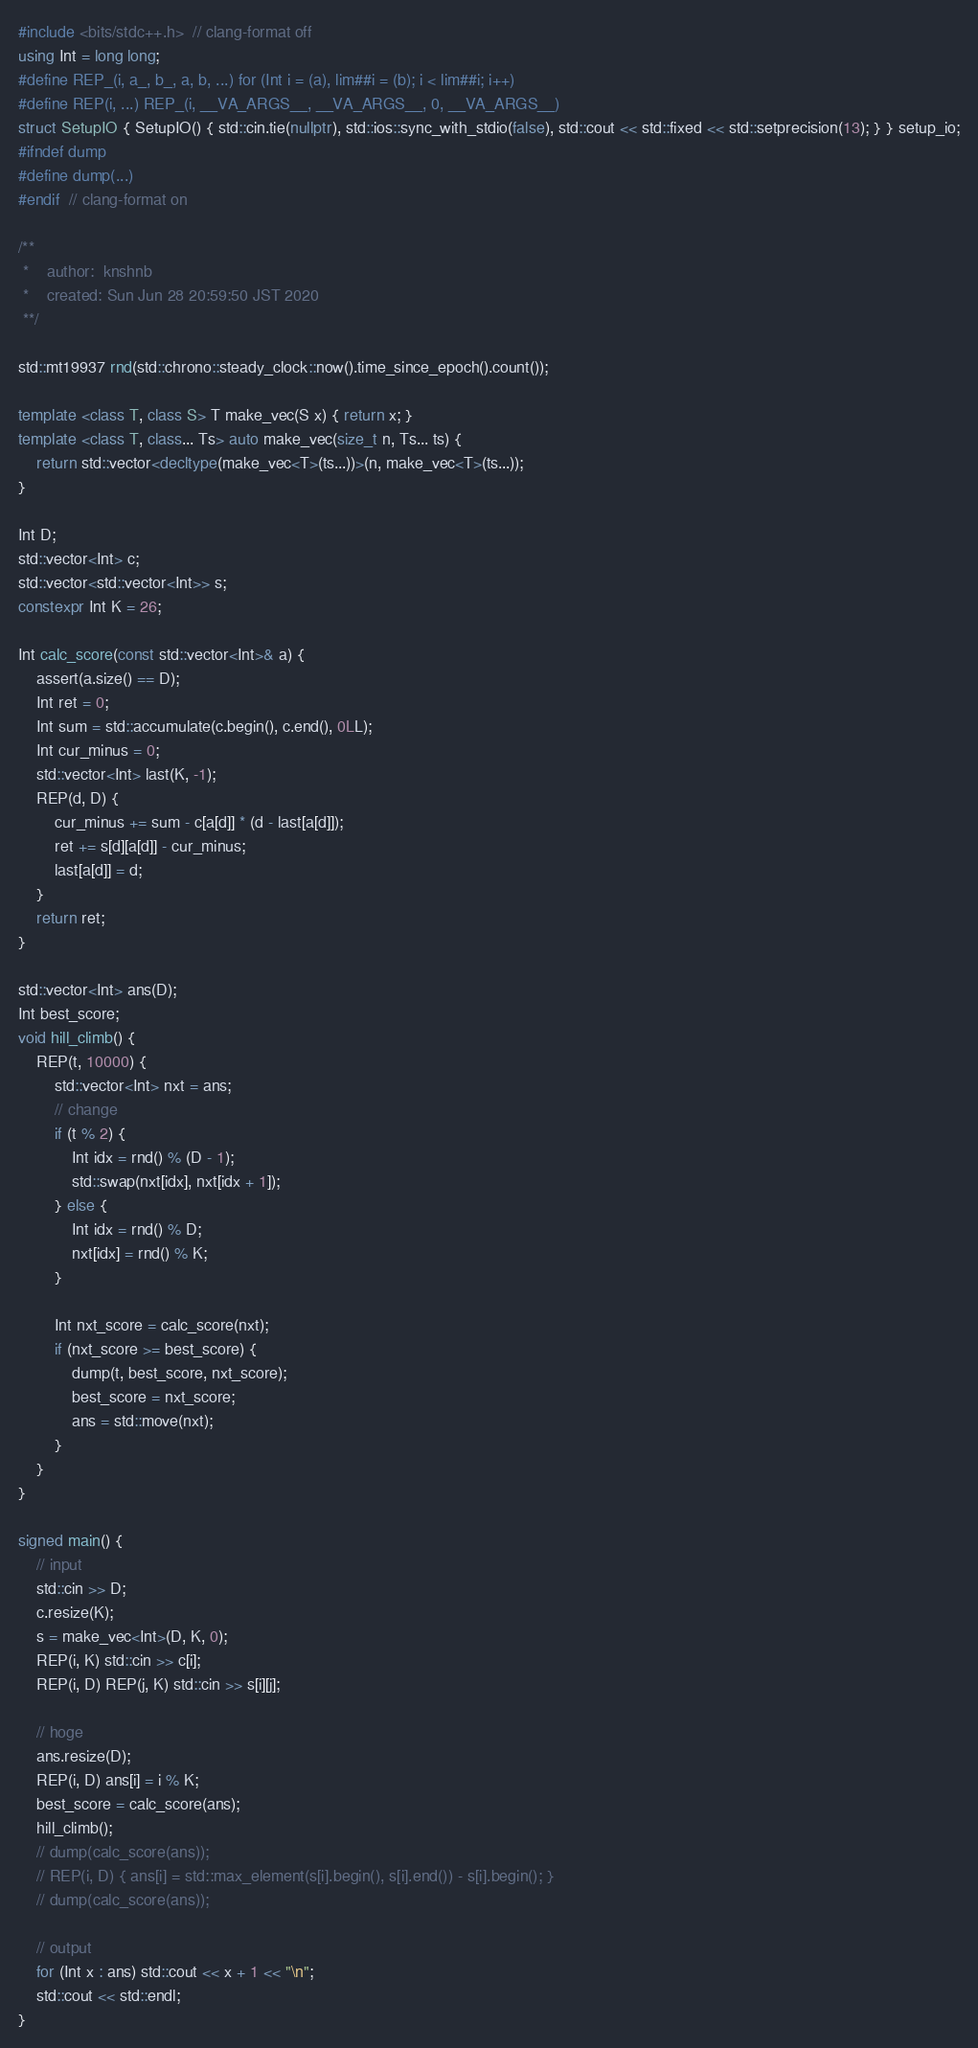Convert code to text. <code><loc_0><loc_0><loc_500><loc_500><_C++_>#include <bits/stdc++.h>  // clang-format off
using Int = long long;
#define REP_(i, a_, b_, a, b, ...) for (Int i = (a), lim##i = (b); i < lim##i; i++)
#define REP(i, ...) REP_(i, __VA_ARGS__, __VA_ARGS__, 0, __VA_ARGS__)
struct SetupIO { SetupIO() { std::cin.tie(nullptr), std::ios::sync_with_stdio(false), std::cout << std::fixed << std::setprecision(13); } } setup_io;
#ifndef dump
#define dump(...)
#endif  // clang-format on

/**
 *    author:  knshnb
 *    created: Sun Jun 28 20:59:50 JST 2020
 **/

std::mt19937 rnd(std::chrono::steady_clock::now().time_since_epoch().count());

template <class T, class S> T make_vec(S x) { return x; }
template <class T, class... Ts> auto make_vec(size_t n, Ts... ts) {
    return std::vector<decltype(make_vec<T>(ts...))>(n, make_vec<T>(ts...));
}

Int D;
std::vector<Int> c;
std::vector<std::vector<Int>> s;
constexpr Int K = 26;

Int calc_score(const std::vector<Int>& a) {
    assert(a.size() == D);
    Int ret = 0;
    Int sum = std::accumulate(c.begin(), c.end(), 0LL);
    Int cur_minus = 0;
    std::vector<Int> last(K, -1);
    REP(d, D) {
        cur_minus += sum - c[a[d]] * (d - last[a[d]]);
        ret += s[d][a[d]] - cur_minus;
        last[a[d]] = d;
    }
    return ret;
}

std::vector<Int> ans(D);
Int best_score;
void hill_climb() {
    REP(t, 10000) {
        std::vector<Int> nxt = ans;
        // change
        if (t % 2) {
            Int idx = rnd() % (D - 1);
            std::swap(nxt[idx], nxt[idx + 1]);
        } else {
            Int idx = rnd() % D;
            nxt[idx] = rnd() % K;
        }

        Int nxt_score = calc_score(nxt);
        if (nxt_score >= best_score) {
            dump(t, best_score, nxt_score);
            best_score = nxt_score;
            ans = std::move(nxt);
        }
    }
}

signed main() {
    // input
    std::cin >> D;
    c.resize(K);
    s = make_vec<Int>(D, K, 0);
    REP(i, K) std::cin >> c[i];
    REP(i, D) REP(j, K) std::cin >> s[i][j];

    // hoge
    ans.resize(D);
    REP(i, D) ans[i] = i % K;
    best_score = calc_score(ans);
    hill_climb();
    // dump(calc_score(ans));
    // REP(i, D) { ans[i] = std::max_element(s[i].begin(), s[i].end()) - s[i].begin(); }
    // dump(calc_score(ans));

    // output
    for (Int x : ans) std::cout << x + 1 << "\n";
    std::cout << std::endl;
}
</code> 